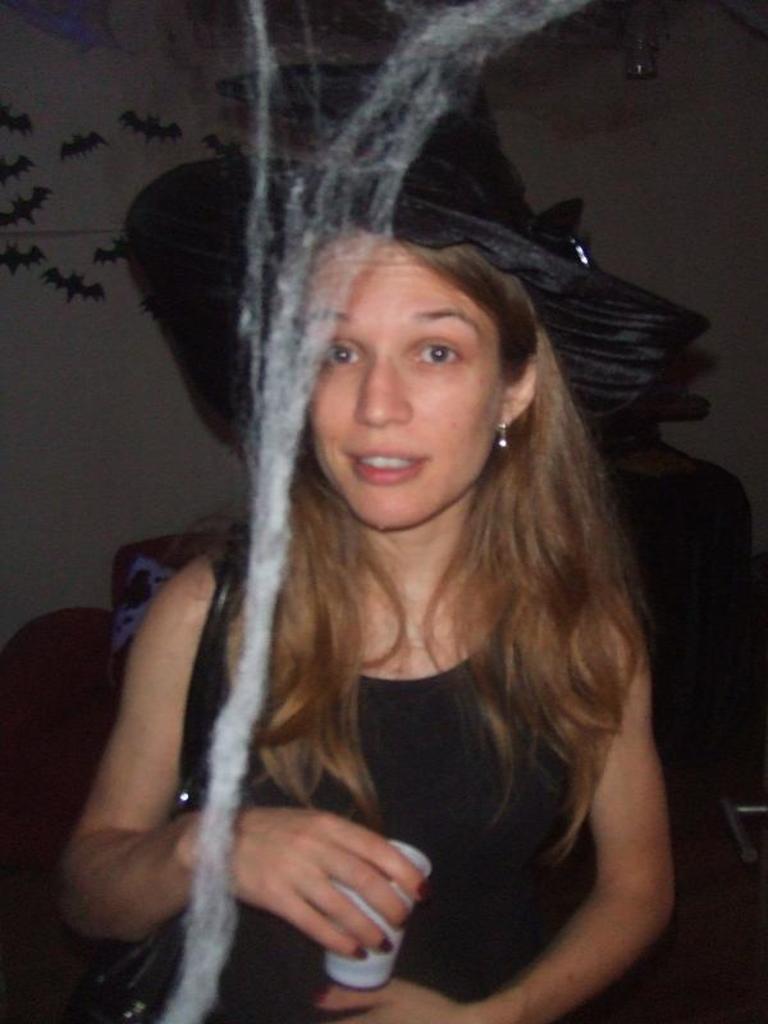How would you summarize this image in a sentence or two? In this picture we can see a woman in the black dress is holding a cup. Behind the woman there is another person and a wall with stickers. In front of the woman there is cotton. 